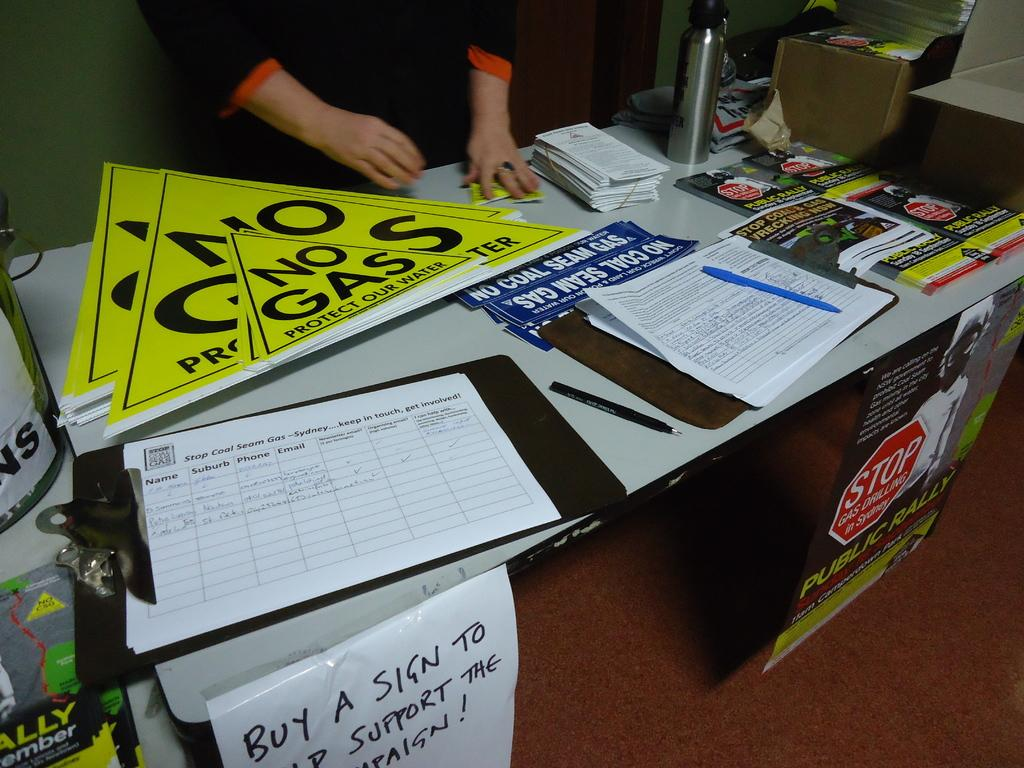<image>
Summarize the visual content of the image. Yellow signs with No Gas sit on a table. 